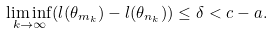Convert formula to latex. <formula><loc_0><loc_0><loc_500><loc_500>\liminf _ { k \rightarrow \infty } ( l ( \theta _ { m _ { k } } ) - l ( \theta _ { n _ { k } } ) ) \leq \delta < c - a .</formula> 